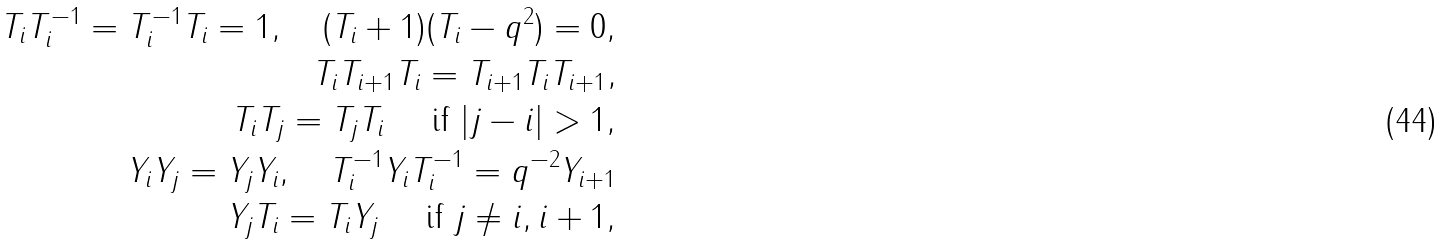Convert formula to latex. <formula><loc_0><loc_0><loc_500><loc_500>T _ { i } T _ { i } ^ { - 1 } = T _ { i } ^ { - 1 } T _ { i } = 1 , \quad ( T _ { i } + 1 ) ( T _ { i } - q ^ { 2 } ) = 0 , \\ T _ { i } T _ { i + 1 } T _ { i } = T _ { i + 1 } T _ { i } T _ { i + 1 } , \\ T _ { i } T _ { j } = T _ { j } T _ { i } \quad \text { if $ |j-i| > 1,$} \\ Y _ { i } Y _ { j } = Y _ { j } Y _ { i } , \quad T _ { i } ^ { - 1 } Y _ { i } T _ { i } ^ { - 1 } = q ^ { - 2 } Y _ { i + 1 } \\ Y _ { j } T _ { i } = T _ { i } Y _ { j } \quad \text { if $ j \neq i,i+1,$}</formula> 